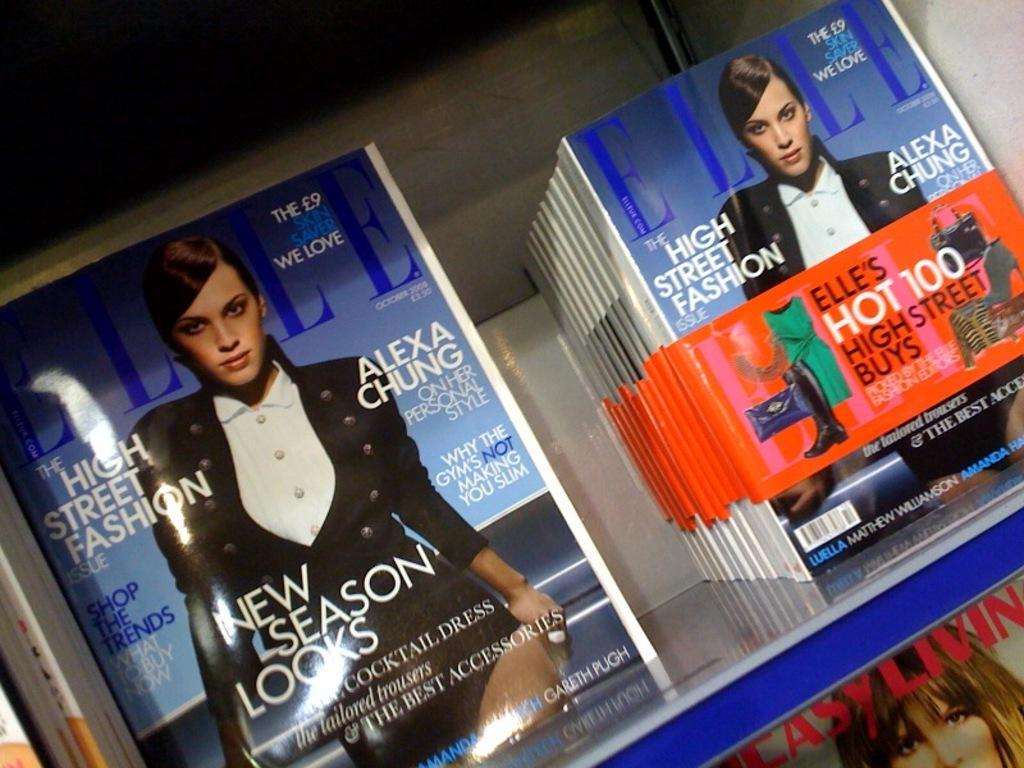Provide a one-sentence caption for the provided image. A bunch of Elle magazine on top of a grey table. 